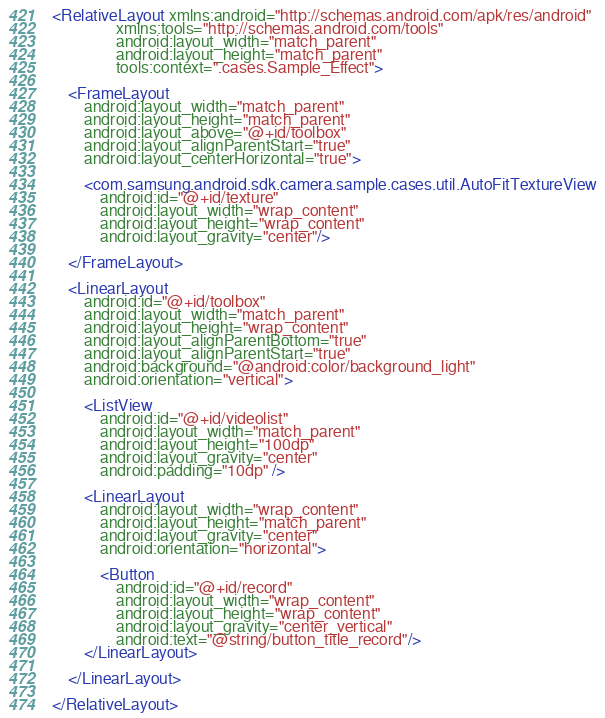Convert code to text. <code><loc_0><loc_0><loc_500><loc_500><_XML_><RelativeLayout xmlns:android="http://schemas.android.com/apk/res/android"
                xmlns:tools="http://schemas.android.com/tools"
                android:layout_width="match_parent"
                android:layout_height="match_parent"
                tools:context=".cases.Sample_Effect">

    <FrameLayout
        android:layout_width="match_parent"
        android:layout_height="match_parent"
        android:layout_above="@+id/toolbox"
        android:layout_alignParentStart="true"
        android:layout_centerHorizontal="true">

        <com.samsung.android.sdk.camera.sample.cases.util.AutoFitTextureView
            android:id="@+id/texture"
            android:layout_width="wrap_content"
            android:layout_height="wrap_content"
            android:layout_gravity="center"/>

    </FrameLayout>

    <LinearLayout
        android:id="@+id/toolbox"
        android:layout_width="match_parent"
        android:layout_height="wrap_content"
        android:layout_alignParentBottom="true"
        android:layout_alignParentStart="true"
        android:background="@android:color/background_light"
        android:orientation="vertical">

        <ListView
            android:id="@+id/videolist"
            android:layout_width="match_parent"
            android:layout_height="100dp"
            android:layout_gravity="center"
            android:padding="10dp" />

        <LinearLayout
            android:layout_width="wrap_content"
            android:layout_height="match_parent"
            android:layout_gravity="center"
            android:orientation="horizontal">

            <Button
                android:id="@+id/record"
                android:layout_width="wrap_content"
                android:layout_height="wrap_content"
                android:layout_gravity="center_vertical"
                android:text="@string/button_title_record"/>
        </LinearLayout>

    </LinearLayout>

</RelativeLayout>
</code> 